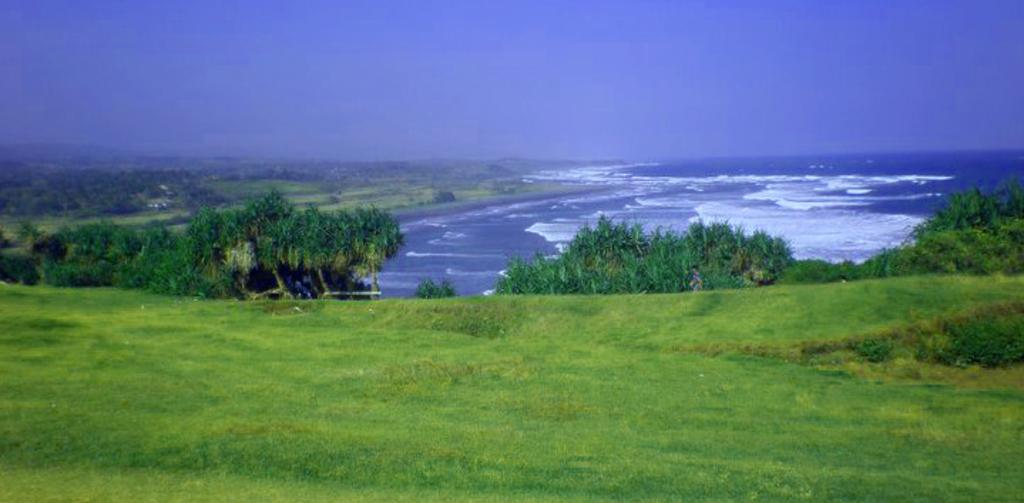What type of vegetation can be seen in the image? There are plants and trees in the image. Where are the plants and trees located? They are on a grassland in the image. What other geographical features can be seen in the image? There is a hill on the left side of the image and water with tides on the right side of the image. What is visible at the top of the image? The sky is visible at the top of the image. What is the tendency of the minister in the image? There is no minister present in the image. How does the competition between the plants and trees affect the grassland? There is no competition between the plants and trees mentioned in the image, as they are not competing with each other. 